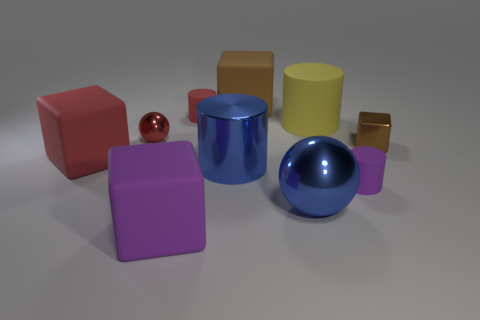Subtract all cubes. How many objects are left? 6 Add 4 big cylinders. How many big cylinders are left? 6 Add 8 blue metallic cylinders. How many blue metallic cylinders exist? 9 Subtract 2 brown blocks. How many objects are left? 8 Subtract all small purple things. Subtract all blocks. How many objects are left? 5 